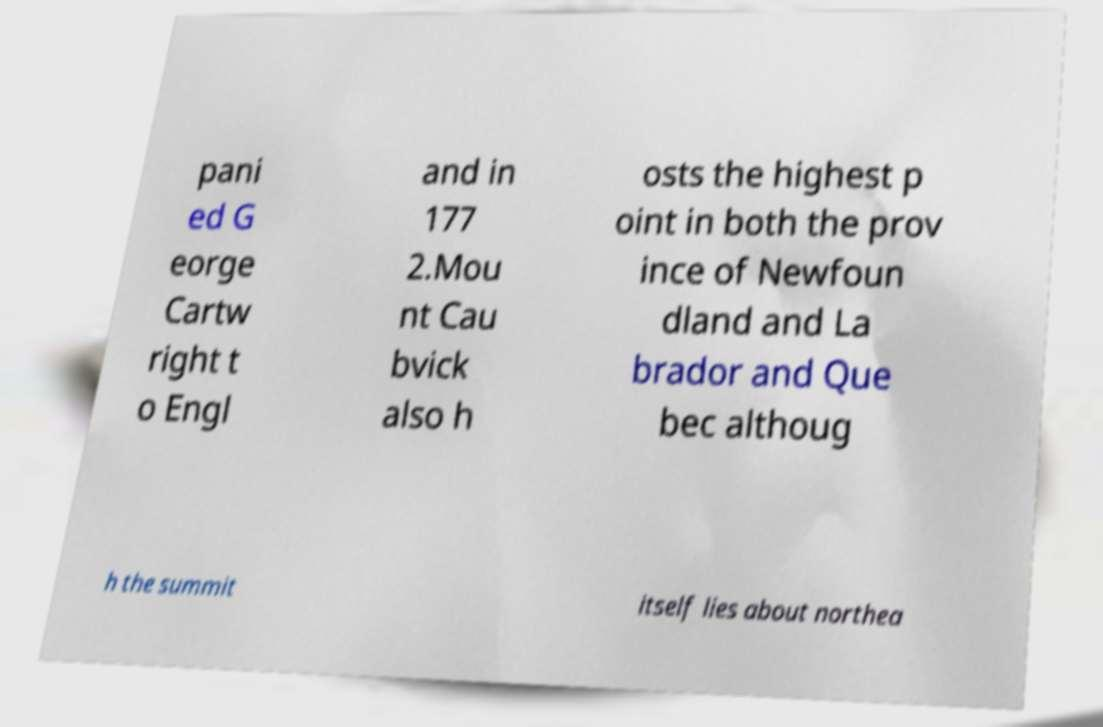For documentation purposes, I need the text within this image transcribed. Could you provide that? pani ed G eorge Cartw right t o Engl and in 177 2.Mou nt Cau bvick also h osts the highest p oint in both the prov ince of Newfoun dland and La brador and Que bec althoug h the summit itself lies about northea 